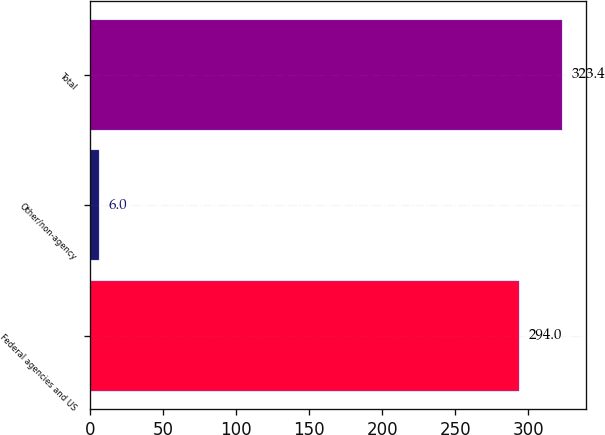<chart> <loc_0><loc_0><loc_500><loc_500><bar_chart><fcel>Federal agencies and US<fcel>Other/non-agency<fcel>Total<nl><fcel>294<fcel>6<fcel>323.4<nl></chart> 